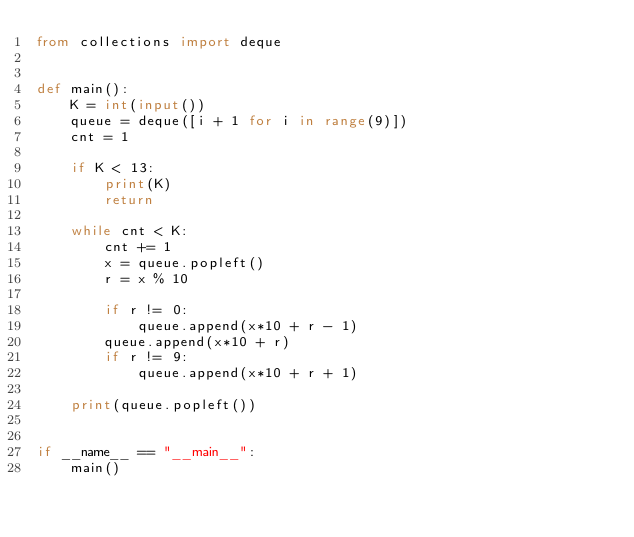<code> <loc_0><loc_0><loc_500><loc_500><_Python_>from collections import deque


def main():
    K = int(input())
    queue = deque([i + 1 for i in range(9)])
    cnt = 1

    if K < 13:
        print(K)
        return

    while cnt < K:
        cnt += 1
        x = queue.popleft()
        r = x % 10

        if r != 0:
            queue.append(x*10 + r - 1)
        queue.append(x*10 + r)
        if r != 9:
            queue.append(x*10 + r + 1)

    print(queue.popleft())


if __name__ == "__main__":
    main()
</code> 